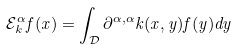<formula> <loc_0><loc_0><loc_500><loc_500>\mathcal { E } _ { k } ^ { \alpha } f ( x ) = \int _ { \mathcal { D } } \partial ^ { \alpha , \alpha } k ( x , y ) f ( y ) d y</formula> 